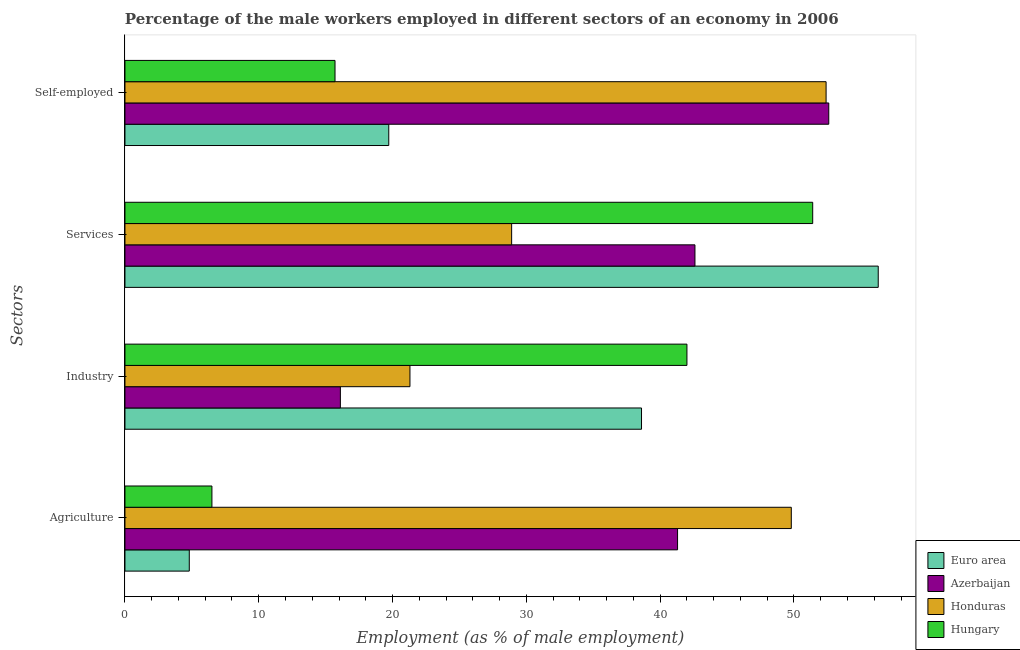How many different coloured bars are there?
Provide a succinct answer. 4. Are the number of bars on each tick of the Y-axis equal?
Keep it short and to the point. Yes. How many bars are there on the 4th tick from the top?
Give a very brief answer. 4. What is the label of the 4th group of bars from the top?
Your response must be concise. Agriculture. What is the percentage of male workers in services in Honduras?
Your response must be concise. 28.9. Across all countries, what is the minimum percentage of male workers in industry?
Make the answer very short. 16.1. In which country was the percentage of male workers in services minimum?
Your answer should be very brief. Honduras. What is the total percentage of male workers in services in the graph?
Make the answer very short. 179.2. What is the difference between the percentage of self employed male workers in Azerbaijan and that in Honduras?
Your response must be concise. 0.2. What is the difference between the percentage of self employed male workers in Azerbaijan and the percentage of male workers in industry in Hungary?
Keep it short and to the point. 10.6. What is the average percentage of self employed male workers per country?
Your response must be concise. 35.1. What is the difference between the percentage of male workers in services and percentage of male workers in agriculture in Hungary?
Offer a very short reply. 44.9. What is the ratio of the percentage of male workers in agriculture in Hungary to that in Honduras?
Keep it short and to the point. 0.13. Is the percentage of male workers in industry in Honduras less than that in Hungary?
Give a very brief answer. Yes. Is the difference between the percentage of male workers in services in Honduras and Hungary greater than the difference between the percentage of self employed male workers in Honduras and Hungary?
Provide a short and direct response. No. What is the difference between the highest and the second highest percentage of self employed male workers?
Offer a terse response. 0.2. What is the difference between the highest and the lowest percentage of male workers in services?
Offer a very short reply. 27.4. In how many countries, is the percentage of male workers in agriculture greater than the average percentage of male workers in agriculture taken over all countries?
Provide a short and direct response. 2. Is the sum of the percentage of male workers in industry in Azerbaijan and Euro area greater than the maximum percentage of male workers in agriculture across all countries?
Provide a succinct answer. Yes. Is it the case that in every country, the sum of the percentage of male workers in industry and percentage of self employed male workers is greater than the sum of percentage of male workers in services and percentage of male workers in agriculture?
Your answer should be compact. No. What does the 3rd bar from the top in Self-employed represents?
Offer a terse response. Azerbaijan. Is it the case that in every country, the sum of the percentage of male workers in agriculture and percentage of male workers in industry is greater than the percentage of male workers in services?
Your answer should be very brief. No. Are the values on the major ticks of X-axis written in scientific E-notation?
Provide a succinct answer. No. Does the graph contain any zero values?
Make the answer very short. No. Where does the legend appear in the graph?
Offer a very short reply. Bottom right. How many legend labels are there?
Give a very brief answer. 4. How are the legend labels stacked?
Offer a terse response. Vertical. What is the title of the graph?
Offer a very short reply. Percentage of the male workers employed in different sectors of an economy in 2006. What is the label or title of the X-axis?
Keep it short and to the point. Employment (as % of male employment). What is the label or title of the Y-axis?
Your response must be concise. Sectors. What is the Employment (as % of male employment) of Euro area in Agriculture?
Offer a very short reply. 4.81. What is the Employment (as % of male employment) of Azerbaijan in Agriculture?
Ensure brevity in your answer.  41.3. What is the Employment (as % of male employment) of Honduras in Agriculture?
Your response must be concise. 49.8. What is the Employment (as % of male employment) in Hungary in Agriculture?
Give a very brief answer. 6.5. What is the Employment (as % of male employment) in Euro area in Industry?
Offer a terse response. 38.61. What is the Employment (as % of male employment) in Azerbaijan in Industry?
Provide a succinct answer. 16.1. What is the Employment (as % of male employment) of Honduras in Industry?
Make the answer very short. 21.3. What is the Employment (as % of male employment) of Euro area in Services?
Ensure brevity in your answer.  56.3. What is the Employment (as % of male employment) of Azerbaijan in Services?
Provide a succinct answer. 42.6. What is the Employment (as % of male employment) in Honduras in Services?
Keep it short and to the point. 28.9. What is the Employment (as % of male employment) of Hungary in Services?
Offer a terse response. 51.4. What is the Employment (as % of male employment) in Euro area in Self-employed?
Make the answer very short. 19.72. What is the Employment (as % of male employment) of Azerbaijan in Self-employed?
Give a very brief answer. 52.6. What is the Employment (as % of male employment) in Honduras in Self-employed?
Give a very brief answer. 52.4. What is the Employment (as % of male employment) of Hungary in Self-employed?
Keep it short and to the point. 15.7. Across all Sectors, what is the maximum Employment (as % of male employment) in Euro area?
Offer a terse response. 56.3. Across all Sectors, what is the maximum Employment (as % of male employment) of Azerbaijan?
Give a very brief answer. 52.6. Across all Sectors, what is the maximum Employment (as % of male employment) of Honduras?
Your answer should be very brief. 52.4. Across all Sectors, what is the maximum Employment (as % of male employment) in Hungary?
Provide a short and direct response. 51.4. Across all Sectors, what is the minimum Employment (as % of male employment) of Euro area?
Provide a short and direct response. 4.81. Across all Sectors, what is the minimum Employment (as % of male employment) in Azerbaijan?
Offer a terse response. 16.1. Across all Sectors, what is the minimum Employment (as % of male employment) of Honduras?
Your answer should be very brief. 21.3. What is the total Employment (as % of male employment) of Euro area in the graph?
Provide a succinct answer. 119.43. What is the total Employment (as % of male employment) in Azerbaijan in the graph?
Your response must be concise. 152.6. What is the total Employment (as % of male employment) in Honduras in the graph?
Your answer should be compact. 152.4. What is the total Employment (as % of male employment) in Hungary in the graph?
Your response must be concise. 115.6. What is the difference between the Employment (as % of male employment) in Euro area in Agriculture and that in Industry?
Give a very brief answer. -33.8. What is the difference between the Employment (as % of male employment) of Azerbaijan in Agriculture and that in Industry?
Offer a terse response. 25.2. What is the difference between the Employment (as % of male employment) in Honduras in Agriculture and that in Industry?
Ensure brevity in your answer.  28.5. What is the difference between the Employment (as % of male employment) of Hungary in Agriculture and that in Industry?
Your answer should be compact. -35.5. What is the difference between the Employment (as % of male employment) in Euro area in Agriculture and that in Services?
Make the answer very short. -51.49. What is the difference between the Employment (as % of male employment) in Azerbaijan in Agriculture and that in Services?
Ensure brevity in your answer.  -1.3. What is the difference between the Employment (as % of male employment) of Honduras in Agriculture and that in Services?
Provide a short and direct response. 20.9. What is the difference between the Employment (as % of male employment) in Hungary in Agriculture and that in Services?
Offer a terse response. -44.9. What is the difference between the Employment (as % of male employment) of Euro area in Agriculture and that in Self-employed?
Make the answer very short. -14.91. What is the difference between the Employment (as % of male employment) in Azerbaijan in Agriculture and that in Self-employed?
Your response must be concise. -11.3. What is the difference between the Employment (as % of male employment) of Honduras in Agriculture and that in Self-employed?
Your answer should be compact. -2.6. What is the difference between the Employment (as % of male employment) of Hungary in Agriculture and that in Self-employed?
Make the answer very short. -9.2. What is the difference between the Employment (as % of male employment) of Euro area in Industry and that in Services?
Your answer should be very brief. -17.69. What is the difference between the Employment (as % of male employment) of Azerbaijan in Industry and that in Services?
Provide a succinct answer. -26.5. What is the difference between the Employment (as % of male employment) in Honduras in Industry and that in Services?
Offer a terse response. -7.6. What is the difference between the Employment (as % of male employment) of Hungary in Industry and that in Services?
Provide a succinct answer. -9.4. What is the difference between the Employment (as % of male employment) in Euro area in Industry and that in Self-employed?
Provide a short and direct response. 18.89. What is the difference between the Employment (as % of male employment) of Azerbaijan in Industry and that in Self-employed?
Make the answer very short. -36.5. What is the difference between the Employment (as % of male employment) of Honduras in Industry and that in Self-employed?
Ensure brevity in your answer.  -31.1. What is the difference between the Employment (as % of male employment) of Hungary in Industry and that in Self-employed?
Provide a short and direct response. 26.3. What is the difference between the Employment (as % of male employment) of Euro area in Services and that in Self-employed?
Offer a very short reply. 36.58. What is the difference between the Employment (as % of male employment) in Honduras in Services and that in Self-employed?
Ensure brevity in your answer.  -23.5. What is the difference between the Employment (as % of male employment) in Hungary in Services and that in Self-employed?
Give a very brief answer. 35.7. What is the difference between the Employment (as % of male employment) of Euro area in Agriculture and the Employment (as % of male employment) of Azerbaijan in Industry?
Make the answer very short. -11.29. What is the difference between the Employment (as % of male employment) of Euro area in Agriculture and the Employment (as % of male employment) of Honduras in Industry?
Give a very brief answer. -16.49. What is the difference between the Employment (as % of male employment) in Euro area in Agriculture and the Employment (as % of male employment) in Hungary in Industry?
Offer a terse response. -37.19. What is the difference between the Employment (as % of male employment) of Azerbaijan in Agriculture and the Employment (as % of male employment) of Honduras in Industry?
Your answer should be very brief. 20. What is the difference between the Employment (as % of male employment) of Azerbaijan in Agriculture and the Employment (as % of male employment) of Hungary in Industry?
Provide a short and direct response. -0.7. What is the difference between the Employment (as % of male employment) in Honduras in Agriculture and the Employment (as % of male employment) in Hungary in Industry?
Your answer should be compact. 7.8. What is the difference between the Employment (as % of male employment) in Euro area in Agriculture and the Employment (as % of male employment) in Azerbaijan in Services?
Keep it short and to the point. -37.79. What is the difference between the Employment (as % of male employment) in Euro area in Agriculture and the Employment (as % of male employment) in Honduras in Services?
Offer a terse response. -24.09. What is the difference between the Employment (as % of male employment) in Euro area in Agriculture and the Employment (as % of male employment) in Hungary in Services?
Your answer should be very brief. -46.59. What is the difference between the Employment (as % of male employment) in Azerbaijan in Agriculture and the Employment (as % of male employment) in Honduras in Services?
Provide a short and direct response. 12.4. What is the difference between the Employment (as % of male employment) in Azerbaijan in Agriculture and the Employment (as % of male employment) in Hungary in Services?
Keep it short and to the point. -10.1. What is the difference between the Employment (as % of male employment) in Honduras in Agriculture and the Employment (as % of male employment) in Hungary in Services?
Offer a very short reply. -1.6. What is the difference between the Employment (as % of male employment) in Euro area in Agriculture and the Employment (as % of male employment) in Azerbaijan in Self-employed?
Make the answer very short. -47.79. What is the difference between the Employment (as % of male employment) in Euro area in Agriculture and the Employment (as % of male employment) in Honduras in Self-employed?
Offer a very short reply. -47.59. What is the difference between the Employment (as % of male employment) in Euro area in Agriculture and the Employment (as % of male employment) in Hungary in Self-employed?
Offer a terse response. -10.89. What is the difference between the Employment (as % of male employment) in Azerbaijan in Agriculture and the Employment (as % of male employment) in Hungary in Self-employed?
Ensure brevity in your answer.  25.6. What is the difference between the Employment (as % of male employment) of Honduras in Agriculture and the Employment (as % of male employment) of Hungary in Self-employed?
Make the answer very short. 34.1. What is the difference between the Employment (as % of male employment) of Euro area in Industry and the Employment (as % of male employment) of Azerbaijan in Services?
Offer a very short reply. -3.99. What is the difference between the Employment (as % of male employment) in Euro area in Industry and the Employment (as % of male employment) in Honduras in Services?
Offer a very short reply. 9.71. What is the difference between the Employment (as % of male employment) of Euro area in Industry and the Employment (as % of male employment) of Hungary in Services?
Your response must be concise. -12.79. What is the difference between the Employment (as % of male employment) of Azerbaijan in Industry and the Employment (as % of male employment) of Hungary in Services?
Provide a succinct answer. -35.3. What is the difference between the Employment (as % of male employment) in Honduras in Industry and the Employment (as % of male employment) in Hungary in Services?
Make the answer very short. -30.1. What is the difference between the Employment (as % of male employment) in Euro area in Industry and the Employment (as % of male employment) in Azerbaijan in Self-employed?
Your answer should be very brief. -13.99. What is the difference between the Employment (as % of male employment) in Euro area in Industry and the Employment (as % of male employment) in Honduras in Self-employed?
Give a very brief answer. -13.79. What is the difference between the Employment (as % of male employment) of Euro area in Industry and the Employment (as % of male employment) of Hungary in Self-employed?
Your answer should be compact. 22.91. What is the difference between the Employment (as % of male employment) of Azerbaijan in Industry and the Employment (as % of male employment) of Honduras in Self-employed?
Give a very brief answer. -36.3. What is the difference between the Employment (as % of male employment) of Azerbaijan in Industry and the Employment (as % of male employment) of Hungary in Self-employed?
Ensure brevity in your answer.  0.4. What is the difference between the Employment (as % of male employment) in Honduras in Industry and the Employment (as % of male employment) in Hungary in Self-employed?
Ensure brevity in your answer.  5.6. What is the difference between the Employment (as % of male employment) in Euro area in Services and the Employment (as % of male employment) in Azerbaijan in Self-employed?
Ensure brevity in your answer.  3.7. What is the difference between the Employment (as % of male employment) in Euro area in Services and the Employment (as % of male employment) in Honduras in Self-employed?
Keep it short and to the point. 3.9. What is the difference between the Employment (as % of male employment) in Euro area in Services and the Employment (as % of male employment) in Hungary in Self-employed?
Your answer should be very brief. 40.6. What is the difference between the Employment (as % of male employment) in Azerbaijan in Services and the Employment (as % of male employment) in Hungary in Self-employed?
Offer a terse response. 26.9. What is the average Employment (as % of male employment) of Euro area per Sectors?
Provide a succinct answer. 29.86. What is the average Employment (as % of male employment) of Azerbaijan per Sectors?
Your response must be concise. 38.15. What is the average Employment (as % of male employment) in Honduras per Sectors?
Make the answer very short. 38.1. What is the average Employment (as % of male employment) in Hungary per Sectors?
Provide a succinct answer. 28.9. What is the difference between the Employment (as % of male employment) in Euro area and Employment (as % of male employment) in Azerbaijan in Agriculture?
Keep it short and to the point. -36.49. What is the difference between the Employment (as % of male employment) of Euro area and Employment (as % of male employment) of Honduras in Agriculture?
Give a very brief answer. -44.99. What is the difference between the Employment (as % of male employment) in Euro area and Employment (as % of male employment) in Hungary in Agriculture?
Offer a terse response. -1.69. What is the difference between the Employment (as % of male employment) in Azerbaijan and Employment (as % of male employment) in Hungary in Agriculture?
Offer a very short reply. 34.8. What is the difference between the Employment (as % of male employment) of Honduras and Employment (as % of male employment) of Hungary in Agriculture?
Offer a very short reply. 43.3. What is the difference between the Employment (as % of male employment) of Euro area and Employment (as % of male employment) of Azerbaijan in Industry?
Keep it short and to the point. 22.51. What is the difference between the Employment (as % of male employment) of Euro area and Employment (as % of male employment) of Honduras in Industry?
Ensure brevity in your answer.  17.31. What is the difference between the Employment (as % of male employment) of Euro area and Employment (as % of male employment) of Hungary in Industry?
Offer a terse response. -3.39. What is the difference between the Employment (as % of male employment) of Azerbaijan and Employment (as % of male employment) of Hungary in Industry?
Provide a short and direct response. -25.9. What is the difference between the Employment (as % of male employment) in Honduras and Employment (as % of male employment) in Hungary in Industry?
Keep it short and to the point. -20.7. What is the difference between the Employment (as % of male employment) in Euro area and Employment (as % of male employment) in Azerbaijan in Services?
Provide a short and direct response. 13.7. What is the difference between the Employment (as % of male employment) of Euro area and Employment (as % of male employment) of Honduras in Services?
Give a very brief answer. 27.4. What is the difference between the Employment (as % of male employment) in Euro area and Employment (as % of male employment) in Hungary in Services?
Your answer should be very brief. 4.9. What is the difference between the Employment (as % of male employment) in Honduras and Employment (as % of male employment) in Hungary in Services?
Your answer should be very brief. -22.5. What is the difference between the Employment (as % of male employment) in Euro area and Employment (as % of male employment) in Azerbaijan in Self-employed?
Keep it short and to the point. -32.88. What is the difference between the Employment (as % of male employment) in Euro area and Employment (as % of male employment) in Honduras in Self-employed?
Your response must be concise. -32.68. What is the difference between the Employment (as % of male employment) of Euro area and Employment (as % of male employment) of Hungary in Self-employed?
Offer a terse response. 4.02. What is the difference between the Employment (as % of male employment) in Azerbaijan and Employment (as % of male employment) in Honduras in Self-employed?
Offer a very short reply. 0.2. What is the difference between the Employment (as % of male employment) in Azerbaijan and Employment (as % of male employment) in Hungary in Self-employed?
Offer a very short reply. 36.9. What is the difference between the Employment (as % of male employment) of Honduras and Employment (as % of male employment) of Hungary in Self-employed?
Offer a terse response. 36.7. What is the ratio of the Employment (as % of male employment) in Euro area in Agriculture to that in Industry?
Give a very brief answer. 0.12. What is the ratio of the Employment (as % of male employment) of Azerbaijan in Agriculture to that in Industry?
Offer a very short reply. 2.57. What is the ratio of the Employment (as % of male employment) in Honduras in Agriculture to that in Industry?
Your response must be concise. 2.34. What is the ratio of the Employment (as % of male employment) of Hungary in Agriculture to that in Industry?
Your answer should be very brief. 0.15. What is the ratio of the Employment (as % of male employment) in Euro area in Agriculture to that in Services?
Give a very brief answer. 0.09. What is the ratio of the Employment (as % of male employment) of Azerbaijan in Agriculture to that in Services?
Keep it short and to the point. 0.97. What is the ratio of the Employment (as % of male employment) of Honduras in Agriculture to that in Services?
Offer a terse response. 1.72. What is the ratio of the Employment (as % of male employment) in Hungary in Agriculture to that in Services?
Offer a very short reply. 0.13. What is the ratio of the Employment (as % of male employment) of Euro area in Agriculture to that in Self-employed?
Offer a terse response. 0.24. What is the ratio of the Employment (as % of male employment) of Azerbaijan in Agriculture to that in Self-employed?
Ensure brevity in your answer.  0.79. What is the ratio of the Employment (as % of male employment) in Honduras in Agriculture to that in Self-employed?
Give a very brief answer. 0.95. What is the ratio of the Employment (as % of male employment) of Hungary in Agriculture to that in Self-employed?
Give a very brief answer. 0.41. What is the ratio of the Employment (as % of male employment) in Euro area in Industry to that in Services?
Your answer should be compact. 0.69. What is the ratio of the Employment (as % of male employment) in Azerbaijan in Industry to that in Services?
Provide a short and direct response. 0.38. What is the ratio of the Employment (as % of male employment) of Honduras in Industry to that in Services?
Offer a very short reply. 0.74. What is the ratio of the Employment (as % of male employment) of Hungary in Industry to that in Services?
Make the answer very short. 0.82. What is the ratio of the Employment (as % of male employment) of Euro area in Industry to that in Self-employed?
Ensure brevity in your answer.  1.96. What is the ratio of the Employment (as % of male employment) of Azerbaijan in Industry to that in Self-employed?
Give a very brief answer. 0.31. What is the ratio of the Employment (as % of male employment) in Honduras in Industry to that in Self-employed?
Offer a terse response. 0.41. What is the ratio of the Employment (as % of male employment) of Hungary in Industry to that in Self-employed?
Offer a terse response. 2.68. What is the ratio of the Employment (as % of male employment) of Euro area in Services to that in Self-employed?
Ensure brevity in your answer.  2.86. What is the ratio of the Employment (as % of male employment) in Azerbaijan in Services to that in Self-employed?
Provide a short and direct response. 0.81. What is the ratio of the Employment (as % of male employment) of Honduras in Services to that in Self-employed?
Give a very brief answer. 0.55. What is the ratio of the Employment (as % of male employment) of Hungary in Services to that in Self-employed?
Offer a terse response. 3.27. What is the difference between the highest and the second highest Employment (as % of male employment) in Euro area?
Offer a terse response. 17.69. What is the difference between the highest and the second highest Employment (as % of male employment) in Honduras?
Keep it short and to the point. 2.6. What is the difference between the highest and the second highest Employment (as % of male employment) in Hungary?
Your answer should be very brief. 9.4. What is the difference between the highest and the lowest Employment (as % of male employment) in Euro area?
Your answer should be compact. 51.49. What is the difference between the highest and the lowest Employment (as % of male employment) in Azerbaijan?
Give a very brief answer. 36.5. What is the difference between the highest and the lowest Employment (as % of male employment) in Honduras?
Your answer should be compact. 31.1. What is the difference between the highest and the lowest Employment (as % of male employment) in Hungary?
Ensure brevity in your answer.  44.9. 